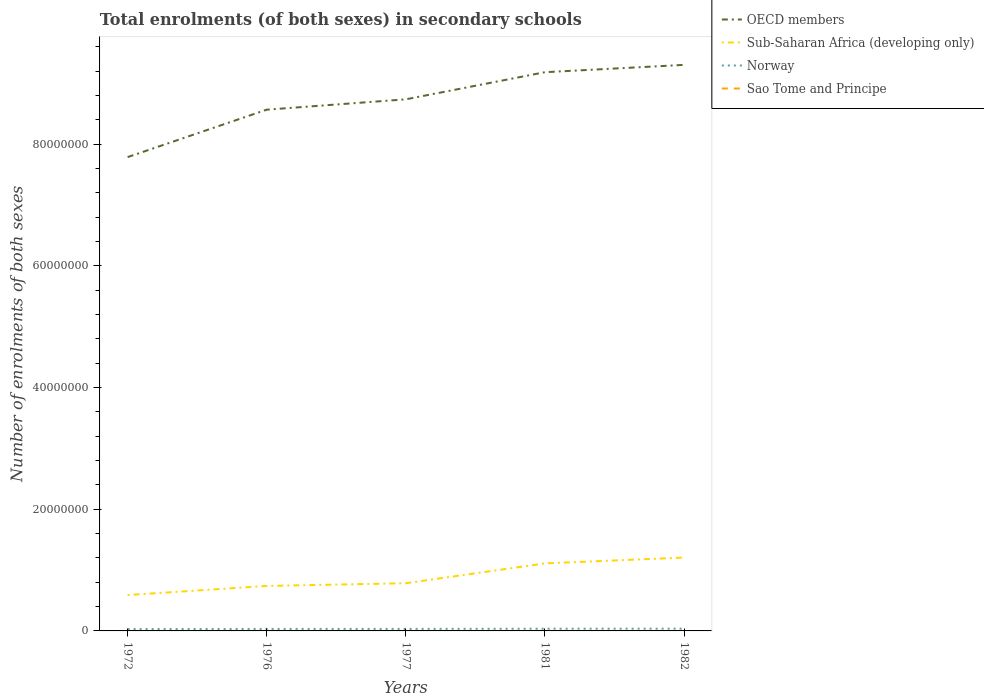How many different coloured lines are there?
Give a very brief answer. 4. Is the number of lines equal to the number of legend labels?
Your answer should be very brief. Yes. Across all years, what is the maximum number of enrolments in secondary schools in Sao Tome and Principe?
Your response must be concise. 1901. What is the total number of enrolments in secondary schools in OECD members in the graph?
Your answer should be very brief. -1.52e+07. What is the difference between the highest and the second highest number of enrolments in secondary schools in OECD members?
Offer a terse response. 1.52e+07. Are the values on the major ticks of Y-axis written in scientific E-notation?
Provide a succinct answer. No. Does the graph contain any zero values?
Make the answer very short. No. Does the graph contain grids?
Make the answer very short. No. Where does the legend appear in the graph?
Give a very brief answer. Top right. How many legend labels are there?
Provide a succinct answer. 4. What is the title of the graph?
Keep it short and to the point. Total enrolments (of both sexes) in secondary schools. Does "Macao" appear as one of the legend labels in the graph?
Offer a terse response. No. What is the label or title of the Y-axis?
Offer a terse response. Number of enrolments of both sexes. What is the Number of enrolments of both sexes in OECD members in 1972?
Your answer should be compact. 7.79e+07. What is the Number of enrolments of both sexes in Sub-Saharan Africa (developing only) in 1972?
Your response must be concise. 5.89e+06. What is the Number of enrolments of both sexes in Norway in 1972?
Offer a terse response. 3.08e+05. What is the Number of enrolments of both sexes of Sao Tome and Principe in 1972?
Your answer should be compact. 1901. What is the Number of enrolments of both sexes in OECD members in 1976?
Give a very brief answer. 8.56e+07. What is the Number of enrolments of both sexes in Sub-Saharan Africa (developing only) in 1976?
Provide a short and direct response. 7.39e+06. What is the Number of enrolments of both sexes in Norway in 1976?
Provide a short and direct response. 3.27e+05. What is the Number of enrolments of both sexes in Sao Tome and Principe in 1976?
Give a very brief answer. 4010. What is the Number of enrolments of both sexes of OECD members in 1977?
Ensure brevity in your answer.  8.73e+07. What is the Number of enrolments of both sexes of Sub-Saharan Africa (developing only) in 1977?
Provide a short and direct response. 7.84e+06. What is the Number of enrolments of both sexes in Norway in 1977?
Provide a succinct answer. 3.30e+05. What is the Number of enrolments of both sexes of Sao Tome and Principe in 1977?
Keep it short and to the point. 3829. What is the Number of enrolments of both sexes of OECD members in 1981?
Provide a succinct answer. 9.18e+07. What is the Number of enrolments of both sexes of Sub-Saharan Africa (developing only) in 1981?
Make the answer very short. 1.11e+07. What is the Number of enrolments of both sexes in Norway in 1981?
Ensure brevity in your answer.  3.61e+05. What is the Number of enrolments of both sexes in Sao Tome and Principe in 1981?
Your response must be concise. 3815. What is the Number of enrolments of both sexes of OECD members in 1982?
Keep it short and to the point. 9.30e+07. What is the Number of enrolments of both sexes of Sub-Saharan Africa (developing only) in 1982?
Provide a short and direct response. 1.21e+07. What is the Number of enrolments of both sexes in Norway in 1982?
Give a very brief answer. 3.69e+05. What is the Number of enrolments of both sexes of Sao Tome and Principe in 1982?
Keep it short and to the point. 4878. Across all years, what is the maximum Number of enrolments of both sexes in OECD members?
Give a very brief answer. 9.30e+07. Across all years, what is the maximum Number of enrolments of both sexes in Sub-Saharan Africa (developing only)?
Offer a terse response. 1.21e+07. Across all years, what is the maximum Number of enrolments of both sexes in Norway?
Provide a succinct answer. 3.69e+05. Across all years, what is the maximum Number of enrolments of both sexes of Sao Tome and Principe?
Provide a short and direct response. 4878. Across all years, what is the minimum Number of enrolments of both sexes in OECD members?
Your answer should be very brief. 7.79e+07. Across all years, what is the minimum Number of enrolments of both sexes of Sub-Saharan Africa (developing only)?
Your answer should be very brief. 5.89e+06. Across all years, what is the minimum Number of enrolments of both sexes of Norway?
Ensure brevity in your answer.  3.08e+05. Across all years, what is the minimum Number of enrolments of both sexes of Sao Tome and Principe?
Give a very brief answer. 1901. What is the total Number of enrolments of both sexes in OECD members in the graph?
Give a very brief answer. 4.36e+08. What is the total Number of enrolments of both sexes in Sub-Saharan Africa (developing only) in the graph?
Offer a very short reply. 4.43e+07. What is the total Number of enrolments of both sexes of Norway in the graph?
Keep it short and to the point. 1.69e+06. What is the total Number of enrolments of both sexes in Sao Tome and Principe in the graph?
Give a very brief answer. 1.84e+04. What is the difference between the Number of enrolments of both sexes of OECD members in 1972 and that in 1976?
Offer a very short reply. -7.79e+06. What is the difference between the Number of enrolments of both sexes of Sub-Saharan Africa (developing only) in 1972 and that in 1976?
Your response must be concise. -1.50e+06. What is the difference between the Number of enrolments of both sexes of Norway in 1972 and that in 1976?
Provide a succinct answer. -1.91e+04. What is the difference between the Number of enrolments of both sexes of Sao Tome and Principe in 1972 and that in 1976?
Make the answer very short. -2109. What is the difference between the Number of enrolments of both sexes in OECD members in 1972 and that in 1977?
Offer a terse response. -9.49e+06. What is the difference between the Number of enrolments of both sexes in Sub-Saharan Africa (developing only) in 1972 and that in 1977?
Your response must be concise. -1.94e+06. What is the difference between the Number of enrolments of both sexes of Norway in 1972 and that in 1977?
Offer a terse response. -2.26e+04. What is the difference between the Number of enrolments of both sexes of Sao Tome and Principe in 1972 and that in 1977?
Provide a short and direct response. -1928. What is the difference between the Number of enrolments of both sexes of OECD members in 1972 and that in 1981?
Give a very brief answer. -1.40e+07. What is the difference between the Number of enrolments of both sexes of Sub-Saharan Africa (developing only) in 1972 and that in 1981?
Make the answer very short. -5.21e+06. What is the difference between the Number of enrolments of both sexes in Norway in 1972 and that in 1981?
Offer a terse response. -5.32e+04. What is the difference between the Number of enrolments of both sexes in Sao Tome and Principe in 1972 and that in 1981?
Ensure brevity in your answer.  -1914. What is the difference between the Number of enrolments of both sexes in OECD members in 1972 and that in 1982?
Provide a short and direct response. -1.52e+07. What is the difference between the Number of enrolments of both sexes of Sub-Saharan Africa (developing only) in 1972 and that in 1982?
Your answer should be compact. -6.16e+06. What is the difference between the Number of enrolments of both sexes in Norway in 1972 and that in 1982?
Make the answer very short. -6.11e+04. What is the difference between the Number of enrolments of both sexes in Sao Tome and Principe in 1972 and that in 1982?
Your answer should be very brief. -2977. What is the difference between the Number of enrolments of both sexes in OECD members in 1976 and that in 1977?
Ensure brevity in your answer.  -1.70e+06. What is the difference between the Number of enrolments of both sexes of Sub-Saharan Africa (developing only) in 1976 and that in 1977?
Offer a very short reply. -4.46e+05. What is the difference between the Number of enrolments of both sexes in Norway in 1976 and that in 1977?
Provide a short and direct response. -3523. What is the difference between the Number of enrolments of both sexes of Sao Tome and Principe in 1976 and that in 1977?
Provide a short and direct response. 181. What is the difference between the Number of enrolments of both sexes in OECD members in 1976 and that in 1981?
Offer a terse response. -6.16e+06. What is the difference between the Number of enrolments of both sexes of Sub-Saharan Africa (developing only) in 1976 and that in 1981?
Offer a very short reply. -3.71e+06. What is the difference between the Number of enrolments of both sexes of Norway in 1976 and that in 1981?
Your response must be concise. -3.41e+04. What is the difference between the Number of enrolments of both sexes in Sao Tome and Principe in 1976 and that in 1981?
Ensure brevity in your answer.  195. What is the difference between the Number of enrolments of both sexes in OECD members in 1976 and that in 1982?
Offer a very short reply. -7.36e+06. What is the difference between the Number of enrolments of both sexes in Sub-Saharan Africa (developing only) in 1976 and that in 1982?
Your answer should be very brief. -4.66e+06. What is the difference between the Number of enrolments of both sexes of Norway in 1976 and that in 1982?
Offer a very short reply. -4.20e+04. What is the difference between the Number of enrolments of both sexes in Sao Tome and Principe in 1976 and that in 1982?
Provide a short and direct response. -868. What is the difference between the Number of enrolments of both sexes in OECD members in 1977 and that in 1981?
Provide a short and direct response. -4.46e+06. What is the difference between the Number of enrolments of both sexes in Sub-Saharan Africa (developing only) in 1977 and that in 1981?
Provide a succinct answer. -3.26e+06. What is the difference between the Number of enrolments of both sexes in Norway in 1977 and that in 1981?
Provide a short and direct response. -3.06e+04. What is the difference between the Number of enrolments of both sexes in Sao Tome and Principe in 1977 and that in 1981?
Make the answer very short. 14. What is the difference between the Number of enrolments of both sexes of OECD members in 1977 and that in 1982?
Ensure brevity in your answer.  -5.66e+06. What is the difference between the Number of enrolments of both sexes in Sub-Saharan Africa (developing only) in 1977 and that in 1982?
Provide a succinct answer. -4.22e+06. What is the difference between the Number of enrolments of both sexes in Norway in 1977 and that in 1982?
Offer a very short reply. -3.85e+04. What is the difference between the Number of enrolments of both sexes in Sao Tome and Principe in 1977 and that in 1982?
Give a very brief answer. -1049. What is the difference between the Number of enrolments of both sexes in OECD members in 1981 and that in 1982?
Provide a succinct answer. -1.20e+06. What is the difference between the Number of enrolments of both sexes of Sub-Saharan Africa (developing only) in 1981 and that in 1982?
Keep it short and to the point. -9.58e+05. What is the difference between the Number of enrolments of both sexes in Norway in 1981 and that in 1982?
Your answer should be compact. -7848. What is the difference between the Number of enrolments of both sexes in Sao Tome and Principe in 1981 and that in 1982?
Make the answer very short. -1063. What is the difference between the Number of enrolments of both sexes of OECD members in 1972 and the Number of enrolments of both sexes of Sub-Saharan Africa (developing only) in 1976?
Your response must be concise. 7.05e+07. What is the difference between the Number of enrolments of both sexes in OECD members in 1972 and the Number of enrolments of both sexes in Norway in 1976?
Offer a terse response. 7.75e+07. What is the difference between the Number of enrolments of both sexes in OECD members in 1972 and the Number of enrolments of both sexes in Sao Tome and Principe in 1976?
Ensure brevity in your answer.  7.79e+07. What is the difference between the Number of enrolments of both sexes of Sub-Saharan Africa (developing only) in 1972 and the Number of enrolments of both sexes of Norway in 1976?
Give a very brief answer. 5.57e+06. What is the difference between the Number of enrolments of both sexes of Sub-Saharan Africa (developing only) in 1972 and the Number of enrolments of both sexes of Sao Tome and Principe in 1976?
Provide a succinct answer. 5.89e+06. What is the difference between the Number of enrolments of both sexes in Norway in 1972 and the Number of enrolments of both sexes in Sao Tome and Principe in 1976?
Provide a succinct answer. 3.04e+05. What is the difference between the Number of enrolments of both sexes in OECD members in 1972 and the Number of enrolments of both sexes in Sub-Saharan Africa (developing only) in 1977?
Offer a very short reply. 7.00e+07. What is the difference between the Number of enrolments of both sexes of OECD members in 1972 and the Number of enrolments of both sexes of Norway in 1977?
Your response must be concise. 7.75e+07. What is the difference between the Number of enrolments of both sexes in OECD members in 1972 and the Number of enrolments of both sexes in Sao Tome and Principe in 1977?
Offer a very short reply. 7.79e+07. What is the difference between the Number of enrolments of both sexes of Sub-Saharan Africa (developing only) in 1972 and the Number of enrolments of both sexes of Norway in 1977?
Offer a terse response. 5.56e+06. What is the difference between the Number of enrolments of both sexes of Sub-Saharan Africa (developing only) in 1972 and the Number of enrolments of both sexes of Sao Tome and Principe in 1977?
Give a very brief answer. 5.89e+06. What is the difference between the Number of enrolments of both sexes in Norway in 1972 and the Number of enrolments of both sexes in Sao Tome and Principe in 1977?
Your answer should be very brief. 3.04e+05. What is the difference between the Number of enrolments of both sexes of OECD members in 1972 and the Number of enrolments of both sexes of Sub-Saharan Africa (developing only) in 1981?
Provide a succinct answer. 6.68e+07. What is the difference between the Number of enrolments of both sexes of OECD members in 1972 and the Number of enrolments of both sexes of Norway in 1981?
Make the answer very short. 7.75e+07. What is the difference between the Number of enrolments of both sexes of OECD members in 1972 and the Number of enrolments of both sexes of Sao Tome and Principe in 1981?
Ensure brevity in your answer.  7.79e+07. What is the difference between the Number of enrolments of both sexes in Sub-Saharan Africa (developing only) in 1972 and the Number of enrolments of both sexes in Norway in 1981?
Offer a very short reply. 5.53e+06. What is the difference between the Number of enrolments of both sexes of Sub-Saharan Africa (developing only) in 1972 and the Number of enrolments of both sexes of Sao Tome and Principe in 1981?
Offer a terse response. 5.89e+06. What is the difference between the Number of enrolments of both sexes in Norway in 1972 and the Number of enrolments of both sexes in Sao Tome and Principe in 1981?
Provide a short and direct response. 3.04e+05. What is the difference between the Number of enrolments of both sexes in OECD members in 1972 and the Number of enrolments of both sexes in Sub-Saharan Africa (developing only) in 1982?
Make the answer very short. 6.58e+07. What is the difference between the Number of enrolments of both sexes of OECD members in 1972 and the Number of enrolments of both sexes of Norway in 1982?
Your answer should be very brief. 7.75e+07. What is the difference between the Number of enrolments of both sexes of OECD members in 1972 and the Number of enrolments of both sexes of Sao Tome and Principe in 1982?
Provide a short and direct response. 7.78e+07. What is the difference between the Number of enrolments of both sexes of Sub-Saharan Africa (developing only) in 1972 and the Number of enrolments of both sexes of Norway in 1982?
Your answer should be very brief. 5.52e+06. What is the difference between the Number of enrolments of both sexes in Sub-Saharan Africa (developing only) in 1972 and the Number of enrolments of both sexes in Sao Tome and Principe in 1982?
Offer a very short reply. 5.89e+06. What is the difference between the Number of enrolments of both sexes in Norway in 1972 and the Number of enrolments of both sexes in Sao Tome and Principe in 1982?
Your answer should be very brief. 3.03e+05. What is the difference between the Number of enrolments of both sexes of OECD members in 1976 and the Number of enrolments of both sexes of Sub-Saharan Africa (developing only) in 1977?
Offer a very short reply. 7.78e+07. What is the difference between the Number of enrolments of both sexes of OECD members in 1976 and the Number of enrolments of both sexes of Norway in 1977?
Keep it short and to the point. 8.53e+07. What is the difference between the Number of enrolments of both sexes in OECD members in 1976 and the Number of enrolments of both sexes in Sao Tome and Principe in 1977?
Provide a short and direct response. 8.56e+07. What is the difference between the Number of enrolments of both sexes in Sub-Saharan Africa (developing only) in 1976 and the Number of enrolments of both sexes in Norway in 1977?
Keep it short and to the point. 7.06e+06. What is the difference between the Number of enrolments of both sexes in Sub-Saharan Africa (developing only) in 1976 and the Number of enrolments of both sexes in Sao Tome and Principe in 1977?
Provide a short and direct response. 7.39e+06. What is the difference between the Number of enrolments of both sexes in Norway in 1976 and the Number of enrolments of both sexes in Sao Tome and Principe in 1977?
Your answer should be compact. 3.23e+05. What is the difference between the Number of enrolments of both sexes of OECD members in 1976 and the Number of enrolments of both sexes of Sub-Saharan Africa (developing only) in 1981?
Your response must be concise. 7.46e+07. What is the difference between the Number of enrolments of both sexes of OECD members in 1976 and the Number of enrolments of both sexes of Norway in 1981?
Make the answer very short. 8.53e+07. What is the difference between the Number of enrolments of both sexes in OECD members in 1976 and the Number of enrolments of both sexes in Sao Tome and Principe in 1981?
Offer a very short reply. 8.56e+07. What is the difference between the Number of enrolments of both sexes in Sub-Saharan Africa (developing only) in 1976 and the Number of enrolments of both sexes in Norway in 1981?
Provide a short and direct response. 7.03e+06. What is the difference between the Number of enrolments of both sexes of Sub-Saharan Africa (developing only) in 1976 and the Number of enrolments of both sexes of Sao Tome and Principe in 1981?
Give a very brief answer. 7.39e+06. What is the difference between the Number of enrolments of both sexes of Norway in 1976 and the Number of enrolments of both sexes of Sao Tome and Principe in 1981?
Offer a very short reply. 3.23e+05. What is the difference between the Number of enrolments of both sexes of OECD members in 1976 and the Number of enrolments of both sexes of Sub-Saharan Africa (developing only) in 1982?
Offer a terse response. 7.36e+07. What is the difference between the Number of enrolments of both sexes in OECD members in 1976 and the Number of enrolments of both sexes in Norway in 1982?
Your answer should be compact. 8.53e+07. What is the difference between the Number of enrolments of both sexes in OECD members in 1976 and the Number of enrolments of both sexes in Sao Tome and Principe in 1982?
Provide a succinct answer. 8.56e+07. What is the difference between the Number of enrolments of both sexes of Sub-Saharan Africa (developing only) in 1976 and the Number of enrolments of both sexes of Norway in 1982?
Your response must be concise. 7.02e+06. What is the difference between the Number of enrolments of both sexes of Sub-Saharan Africa (developing only) in 1976 and the Number of enrolments of both sexes of Sao Tome and Principe in 1982?
Offer a very short reply. 7.39e+06. What is the difference between the Number of enrolments of both sexes of Norway in 1976 and the Number of enrolments of both sexes of Sao Tome and Principe in 1982?
Give a very brief answer. 3.22e+05. What is the difference between the Number of enrolments of both sexes in OECD members in 1977 and the Number of enrolments of both sexes in Sub-Saharan Africa (developing only) in 1981?
Your answer should be compact. 7.63e+07. What is the difference between the Number of enrolments of both sexes of OECD members in 1977 and the Number of enrolments of both sexes of Norway in 1981?
Offer a terse response. 8.70e+07. What is the difference between the Number of enrolments of both sexes of OECD members in 1977 and the Number of enrolments of both sexes of Sao Tome and Principe in 1981?
Provide a short and direct response. 8.73e+07. What is the difference between the Number of enrolments of both sexes of Sub-Saharan Africa (developing only) in 1977 and the Number of enrolments of both sexes of Norway in 1981?
Give a very brief answer. 7.48e+06. What is the difference between the Number of enrolments of both sexes in Sub-Saharan Africa (developing only) in 1977 and the Number of enrolments of both sexes in Sao Tome and Principe in 1981?
Your response must be concise. 7.83e+06. What is the difference between the Number of enrolments of both sexes in Norway in 1977 and the Number of enrolments of both sexes in Sao Tome and Principe in 1981?
Your answer should be compact. 3.26e+05. What is the difference between the Number of enrolments of both sexes in OECD members in 1977 and the Number of enrolments of both sexes in Sub-Saharan Africa (developing only) in 1982?
Your response must be concise. 7.53e+07. What is the difference between the Number of enrolments of both sexes in OECD members in 1977 and the Number of enrolments of both sexes in Norway in 1982?
Provide a short and direct response. 8.70e+07. What is the difference between the Number of enrolments of both sexes in OECD members in 1977 and the Number of enrolments of both sexes in Sao Tome and Principe in 1982?
Your answer should be compact. 8.73e+07. What is the difference between the Number of enrolments of both sexes of Sub-Saharan Africa (developing only) in 1977 and the Number of enrolments of both sexes of Norway in 1982?
Your answer should be very brief. 7.47e+06. What is the difference between the Number of enrolments of both sexes of Sub-Saharan Africa (developing only) in 1977 and the Number of enrolments of both sexes of Sao Tome and Principe in 1982?
Your response must be concise. 7.83e+06. What is the difference between the Number of enrolments of both sexes in Norway in 1977 and the Number of enrolments of both sexes in Sao Tome and Principe in 1982?
Your answer should be very brief. 3.25e+05. What is the difference between the Number of enrolments of both sexes of OECD members in 1981 and the Number of enrolments of both sexes of Sub-Saharan Africa (developing only) in 1982?
Ensure brevity in your answer.  7.97e+07. What is the difference between the Number of enrolments of both sexes in OECD members in 1981 and the Number of enrolments of both sexes in Norway in 1982?
Ensure brevity in your answer.  9.14e+07. What is the difference between the Number of enrolments of both sexes of OECD members in 1981 and the Number of enrolments of both sexes of Sao Tome and Principe in 1982?
Your response must be concise. 9.18e+07. What is the difference between the Number of enrolments of both sexes of Sub-Saharan Africa (developing only) in 1981 and the Number of enrolments of both sexes of Norway in 1982?
Keep it short and to the point. 1.07e+07. What is the difference between the Number of enrolments of both sexes of Sub-Saharan Africa (developing only) in 1981 and the Number of enrolments of both sexes of Sao Tome and Principe in 1982?
Your response must be concise. 1.11e+07. What is the difference between the Number of enrolments of both sexes in Norway in 1981 and the Number of enrolments of both sexes in Sao Tome and Principe in 1982?
Offer a terse response. 3.56e+05. What is the average Number of enrolments of both sexes of OECD members per year?
Offer a terse response. 8.71e+07. What is the average Number of enrolments of both sexes of Sub-Saharan Africa (developing only) per year?
Offer a terse response. 8.85e+06. What is the average Number of enrolments of both sexes of Norway per year?
Offer a very short reply. 3.39e+05. What is the average Number of enrolments of both sexes of Sao Tome and Principe per year?
Offer a terse response. 3686.6. In the year 1972, what is the difference between the Number of enrolments of both sexes in OECD members and Number of enrolments of both sexes in Sub-Saharan Africa (developing only)?
Your answer should be compact. 7.20e+07. In the year 1972, what is the difference between the Number of enrolments of both sexes of OECD members and Number of enrolments of both sexes of Norway?
Give a very brief answer. 7.75e+07. In the year 1972, what is the difference between the Number of enrolments of both sexes in OECD members and Number of enrolments of both sexes in Sao Tome and Principe?
Your answer should be very brief. 7.79e+07. In the year 1972, what is the difference between the Number of enrolments of both sexes in Sub-Saharan Africa (developing only) and Number of enrolments of both sexes in Norway?
Provide a short and direct response. 5.58e+06. In the year 1972, what is the difference between the Number of enrolments of both sexes in Sub-Saharan Africa (developing only) and Number of enrolments of both sexes in Sao Tome and Principe?
Offer a very short reply. 5.89e+06. In the year 1972, what is the difference between the Number of enrolments of both sexes of Norway and Number of enrolments of both sexes of Sao Tome and Principe?
Give a very brief answer. 3.06e+05. In the year 1976, what is the difference between the Number of enrolments of both sexes of OECD members and Number of enrolments of both sexes of Sub-Saharan Africa (developing only)?
Provide a succinct answer. 7.83e+07. In the year 1976, what is the difference between the Number of enrolments of both sexes in OECD members and Number of enrolments of both sexes in Norway?
Your answer should be compact. 8.53e+07. In the year 1976, what is the difference between the Number of enrolments of both sexes in OECD members and Number of enrolments of both sexes in Sao Tome and Principe?
Your answer should be compact. 8.56e+07. In the year 1976, what is the difference between the Number of enrolments of both sexes in Sub-Saharan Africa (developing only) and Number of enrolments of both sexes in Norway?
Your answer should be very brief. 7.07e+06. In the year 1976, what is the difference between the Number of enrolments of both sexes of Sub-Saharan Africa (developing only) and Number of enrolments of both sexes of Sao Tome and Principe?
Provide a short and direct response. 7.39e+06. In the year 1976, what is the difference between the Number of enrolments of both sexes in Norway and Number of enrolments of both sexes in Sao Tome and Principe?
Keep it short and to the point. 3.23e+05. In the year 1977, what is the difference between the Number of enrolments of both sexes in OECD members and Number of enrolments of both sexes in Sub-Saharan Africa (developing only)?
Provide a succinct answer. 7.95e+07. In the year 1977, what is the difference between the Number of enrolments of both sexes of OECD members and Number of enrolments of both sexes of Norway?
Offer a very short reply. 8.70e+07. In the year 1977, what is the difference between the Number of enrolments of both sexes in OECD members and Number of enrolments of both sexes in Sao Tome and Principe?
Your response must be concise. 8.73e+07. In the year 1977, what is the difference between the Number of enrolments of both sexes in Sub-Saharan Africa (developing only) and Number of enrolments of both sexes in Norway?
Make the answer very short. 7.51e+06. In the year 1977, what is the difference between the Number of enrolments of both sexes of Sub-Saharan Africa (developing only) and Number of enrolments of both sexes of Sao Tome and Principe?
Your answer should be very brief. 7.83e+06. In the year 1977, what is the difference between the Number of enrolments of both sexes in Norway and Number of enrolments of both sexes in Sao Tome and Principe?
Your answer should be very brief. 3.26e+05. In the year 1981, what is the difference between the Number of enrolments of both sexes of OECD members and Number of enrolments of both sexes of Sub-Saharan Africa (developing only)?
Provide a succinct answer. 8.07e+07. In the year 1981, what is the difference between the Number of enrolments of both sexes in OECD members and Number of enrolments of both sexes in Norway?
Your answer should be very brief. 9.14e+07. In the year 1981, what is the difference between the Number of enrolments of both sexes of OECD members and Number of enrolments of both sexes of Sao Tome and Principe?
Ensure brevity in your answer.  9.18e+07. In the year 1981, what is the difference between the Number of enrolments of both sexes in Sub-Saharan Africa (developing only) and Number of enrolments of both sexes in Norway?
Your answer should be very brief. 1.07e+07. In the year 1981, what is the difference between the Number of enrolments of both sexes in Sub-Saharan Africa (developing only) and Number of enrolments of both sexes in Sao Tome and Principe?
Offer a terse response. 1.11e+07. In the year 1981, what is the difference between the Number of enrolments of both sexes in Norway and Number of enrolments of both sexes in Sao Tome and Principe?
Give a very brief answer. 3.57e+05. In the year 1982, what is the difference between the Number of enrolments of both sexes of OECD members and Number of enrolments of both sexes of Sub-Saharan Africa (developing only)?
Ensure brevity in your answer.  8.10e+07. In the year 1982, what is the difference between the Number of enrolments of both sexes of OECD members and Number of enrolments of both sexes of Norway?
Provide a succinct answer. 9.26e+07. In the year 1982, what is the difference between the Number of enrolments of both sexes in OECD members and Number of enrolments of both sexes in Sao Tome and Principe?
Ensure brevity in your answer.  9.30e+07. In the year 1982, what is the difference between the Number of enrolments of both sexes in Sub-Saharan Africa (developing only) and Number of enrolments of both sexes in Norway?
Provide a succinct answer. 1.17e+07. In the year 1982, what is the difference between the Number of enrolments of both sexes of Sub-Saharan Africa (developing only) and Number of enrolments of both sexes of Sao Tome and Principe?
Make the answer very short. 1.21e+07. In the year 1982, what is the difference between the Number of enrolments of both sexes in Norway and Number of enrolments of both sexes in Sao Tome and Principe?
Offer a very short reply. 3.64e+05. What is the ratio of the Number of enrolments of both sexes in OECD members in 1972 to that in 1976?
Your response must be concise. 0.91. What is the ratio of the Number of enrolments of both sexes in Sub-Saharan Africa (developing only) in 1972 to that in 1976?
Offer a very short reply. 0.8. What is the ratio of the Number of enrolments of both sexes in Norway in 1972 to that in 1976?
Give a very brief answer. 0.94. What is the ratio of the Number of enrolments of both sexes in Sao Tome and Principe in 1972 to that in 1976?
Offer a very short reply. 0.47. What is the ratio of the Number of enrolments of both sexes in OECD members in 1972 to that in 1977?
Offer a very short reply. 0.89. What is the ratio of the Number of enrolments of both sexes of Sub-Saharan Africa (developing only) in 1972 to that in 1977?
Provide a succinct answer. 0.75. What is the ratio of the Number of enrolments of both sexes of Norway in 1972 to that in 1977?
Provide a succinct answer. 0.93. What is the ratio of the Number of enrolments of both sexes in Sao Tome and Principe in 1972 to that in 1977?
Your answer should be very brief. 0.5. What is the ratio of the Number of enrolments of both sexes in OECD members in 1972 to that in 1981?
Offer a very short reply. 0.85. What is the ratio of the Number of enrolments of both sexes of Sub-Saharan Africa (developing only) in 1972 to that in 1981?
Your response must be concise. 0.53. What is the ratio of the Number of enrolments of both sexes of Norway in 1972 to that in 1981?
Offer a very short reply. 0.85. What is the ratio of the Number of enrolments of both sexes of Sao Tome and Principe in 1972 to that in 1981?
Ensure brevity in your answer.  0.5. What is the ratio of the Number of enrolments of both sexes of OECD members in 1972 to that in 1982?
Provide a short and direct response. 0.84. What is the ratio of the Number of enrolments of both sexes of Sub-Saharan Africa (developing only) in 1972 to that in 1982?
Provide a succinct answer. 0.49. What is the ratio of the Number of enrolments of both sexes in Norway in 1972 to that in 1982?
Provide a short and direct response. 0.83. What is the ratio of the Number of enrolments of both sexes in Sao Tome and Principe in 1972 to that in 1982?
Keep it short and to the point. 0.39. What is the ratio of the Number of enrolments of both sexes in OECD members in 1976 to that in 1977?
Offer a terse response. 0.98. What is the ratio of the Number of enrolments of both sexes in Sub-Saharan Africa (developing only) in 1976 to that in 1977?
Offer a very short reply. 0.94. What is the ratio of the Number of enrolments of both sexes in Norway in 1976 to that in 1977?
Offer a very short reply. 0.99. What is the ratio of the Number of enrolments of both sexes in Sao Tome and Principe in 1976 to that in 1977?
Provide a short and direct response. 1.05. What is the ratio of the Number of enrolments of both sexes of OECD members in 1976 to that in 1981?
Ensure brevity in your answer.  0.93. What is the ratio of the Number of enrolments of both sexes of Sub-Saharan Africa (developing only) in 1976 to that in 1981?
Make the answer very short. 0.67. What is the ratio of the Number of enrolments of both sexes in Norway in 1976 to that in 1981?
Your answer should be compact. 0.91. What is the ratio of the Number of enrolments of both sexes in Sao Tome and Principe in 1976 to that in 1981?
Give a very brief answer. 1.05. What is the ratio of the Number of enrolments of both sexes in OECD members in 1976 to that in 1982?
Ensure brevity in your answer.  0.92. What is the ratio of the Number of enrolments of both sexes in Sub-Saharan Africa (developing only) in 1976 to that in 1982?
Keep it short and to the point. 0.61. What is the ratio of the Number of enrolments of both sexes in Norway in 1976 to that in 1982?
Keep it short and to the point. 0.89. What is the ratio of the Number of enrolments of both sexes of Sao Tome and Principe in 1976 to that in 1982?
Offer a terse response. 0.82. What is the ratio of the Number of enrolments of both sexes of OECD members in 1977 to that in 1981?
Your answer should be compact. 0.95. What is the ratio of the Number of enrolments of both sexes in Sub-Saharan Africa (developing only) in 1977 to that in 1981?
Give a very brief answer. 0.71. What is the ratio of the Number of enrolments of both sexes of Norway in 1977 to that in 1981?
Give a very brief answer. 0.92. What is the ratio of the Number of enrolments of both sexes in OECD members in 1977 to that in 1982?
Ensure brevity in your answer.  0.94. What is the ratio of the Number of enrolments of both sexes in Sub-Saharan Africa (developing only) in 1977 to that in 1982?
Give a very brief answer. 0.65. What is the ratio of the Number of enrolments of both sexes in Norway in 1977 to that in 1982?
Your response must be concise. 0.9. What is the ratio of the Number of enrolments of both sexes in Sao Tome and Principe in 1977 to that in 1982?
Provide a short and direct response. 0.79. What is the ratio of the Number of enrolments of both sexes in OECD members in 1981 to that in 1982?
Your answer should be compact. 0.99. What is the ratio of the Number of enrolments of both sexes in Sub-Saharan Africa (developing only) in 1981 to that in 1982?
Offer a terse response. 0.92. What is the ratio of the Number of enrolments of both sexes in Norway in 1981 to that in 1982?
Your answer should be very brief. 0.98. What is the ratio of the Number of enrolments of both sexes in Sao Tome and Principe in 1981 to that in 1982?
Keep it short and to the point. 0.78. What is the difference between the highest and the second highest Number of enrolments of both sexes in OECD members?
Provide a succinct answer. 1.20e+06. What is the difference between the highest and the second highest Number of enrolments of both sexes in Sub-Saharan Africa (developing only)?
Provide a short and direct response. 9.58e+05. What is the difference between the highest and the second highest Number of enrolments of both sexes of Norway?
Keep it short and to the point. 7848. What is the difference between the highest and the second highest Number of enrolments of both sexes of Sao Tome and Principe?
Provide a succinct answer. 868. What is the difference between the highest and the lowest Number of enrolments of both sexes of OECD members?
Give a very brief answer. 1.52e+07. What is the difference between the highest and the lowest Number of enrolments of both sexes in Sub-Saharan Africa (developing only)?
Keep it short and to the point. 6.16e+06. What is the difference between the highest and the lowest Number of enrolments of both sexes in Norway?
Offer a terse response. 6.11e+04. What is the difference between the highest and the lowest Number of enrolments of both sexes in Sao Tome and Principe?
Make the answer very short. 2977. 